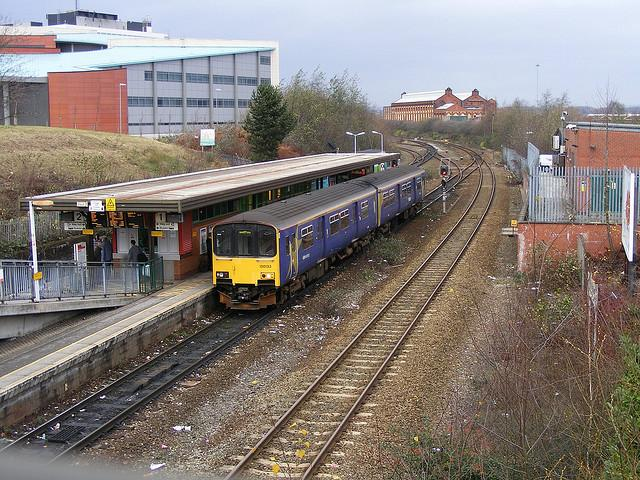At which building does the purple train stop?

Choices:
A) depot
B) bus stop
C) airport
D) school depot 